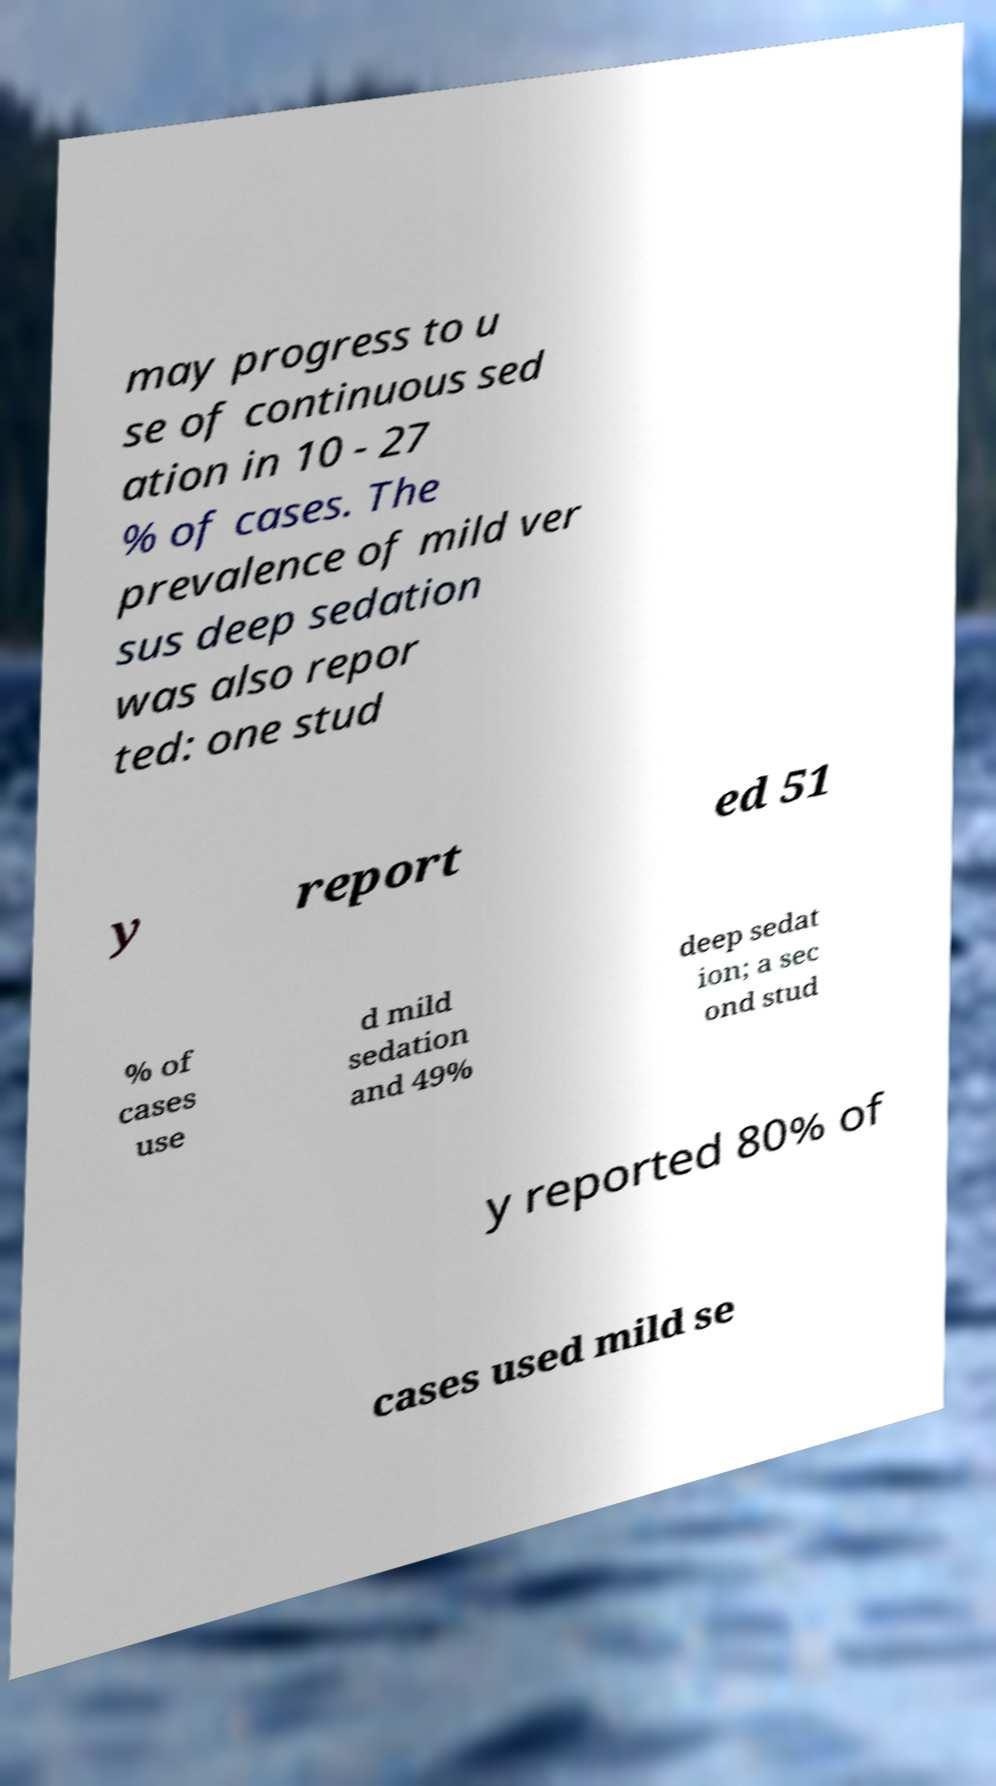Please read and relay the text visible in this image. What does it say? may progress to u se of continuous sed ation in 10 - 27 % of cases. The prevalence of mild ver sus deep sedation was also repor ted: one stud y report ed 51 % of cases use d mild sedation and 49% deep sedat ion; a sec ond stud y reported 80% of cases used mild se 